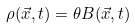Convert formula to latex. <formula><loc_0><loc_0><loc_500><loc_500>\rho ( \vec { x } , t ) = \theta B ( \vec { x } , t )</formula> 